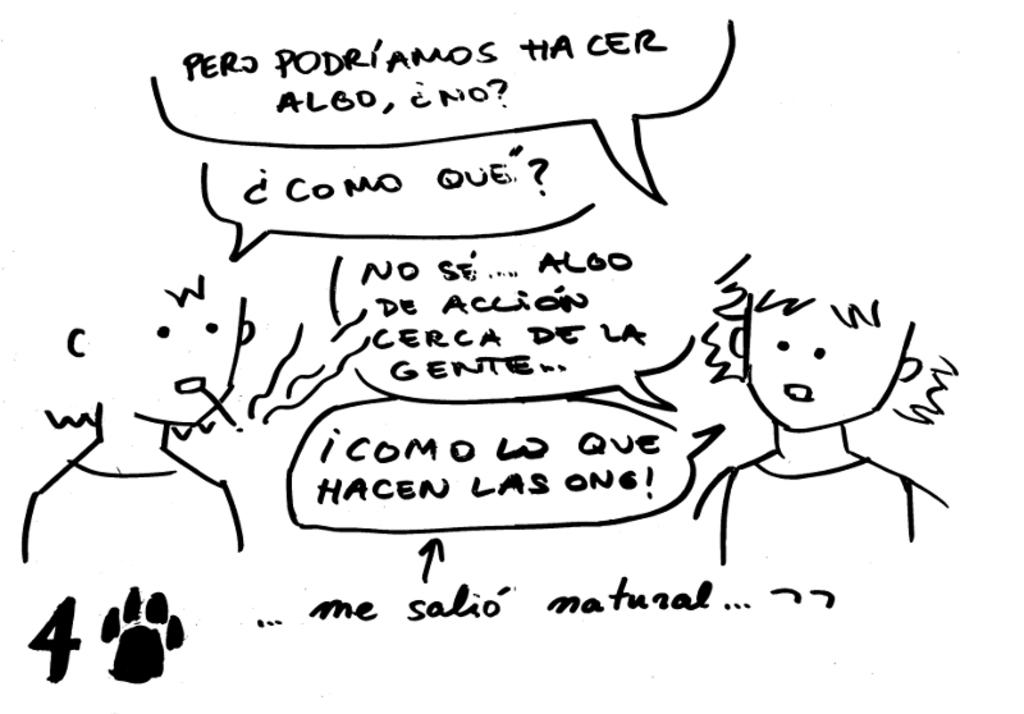What is depicted in the image? The image contains a sketch of two persons. Are there any words or phrases in the image? Yes, there is text in the image. What color is the background of the image? The background of the image is white. How many years does the camp in the image last? There is no camp present in the image, so it is not possible to determine the duration of any camp. 